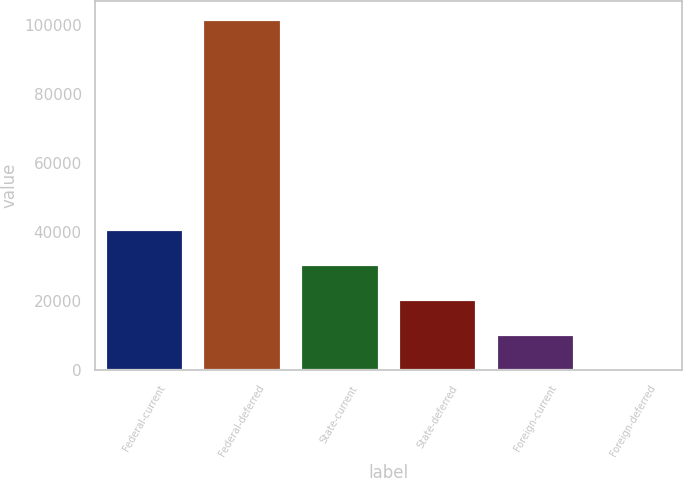Convert chart to OTSL. <chart><loc_0><loc_0><loc_500><loc_500><bar_chart><fcel>Federal-current<fcel>Federal-deferred<fcel>State-current<fcel>State-deferred<fcel>Foreign-current<fcel>Foreign-deferred<nl><fcel>41037.8<fcel>101837<fcel>30904.6<fcel>20771.4<fcel>10638.2<fcel>505<nl></chart> 